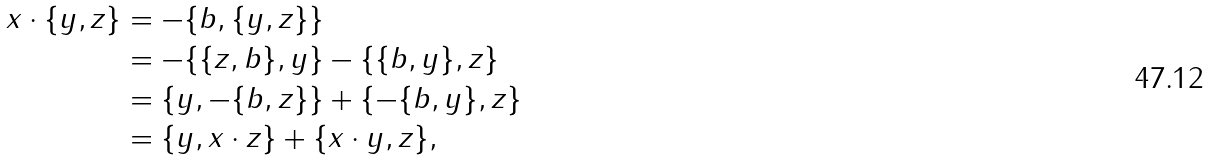<formula> <loc_0><loc_0><loc_500><loc_500>x \cdot \{ y , z \} & = - \{ b , \{ y , z \} \} \\ & = - \{ \{ z , b \} , y \} - \{ \{ b , y \} , z \} \\ & = \{ y , - \{ b , z \} \} + \{ - \{ b , y \} , z \} \\ & = \{ y , x \cdot z \} + \{ x \cdot y , z \} ,</formula> 